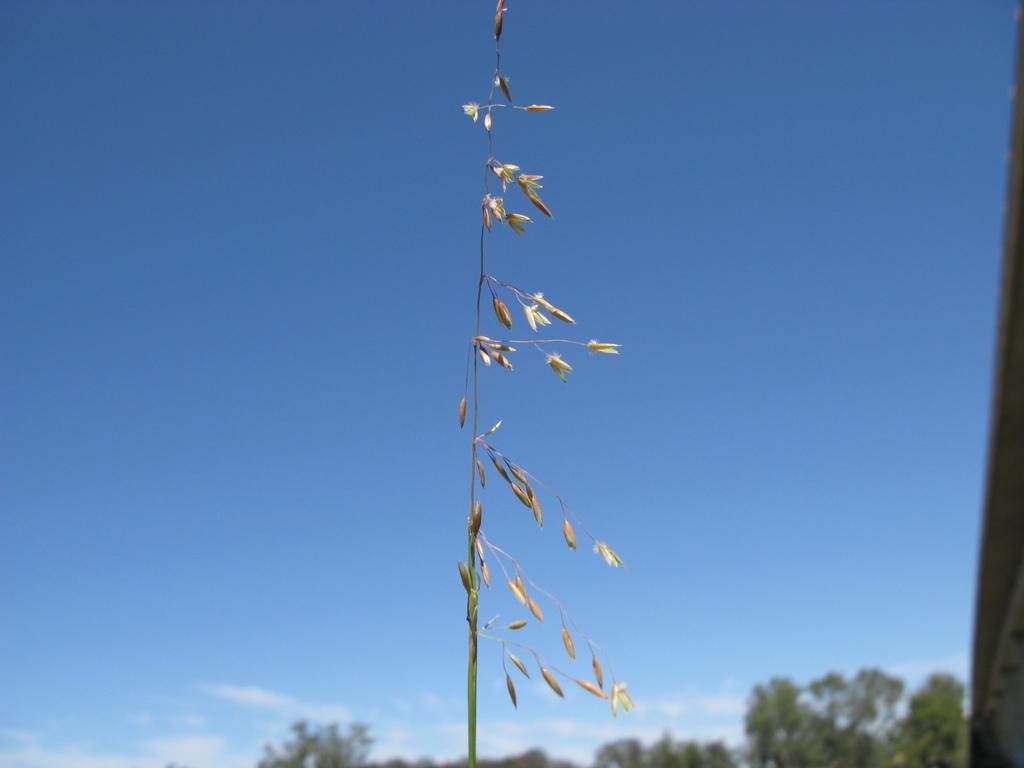What type of vegetation can be seen in the image? There are plants and trees in the image. What is visible in the background of the image? The sky is visible in the background of the image. What can be observed in the sky? Clouds are present in the sky. What type of skirt is hanging on the wall in the image? There is no skirt or wall present in the image; it features plants, trees, and a sky with clouds. 